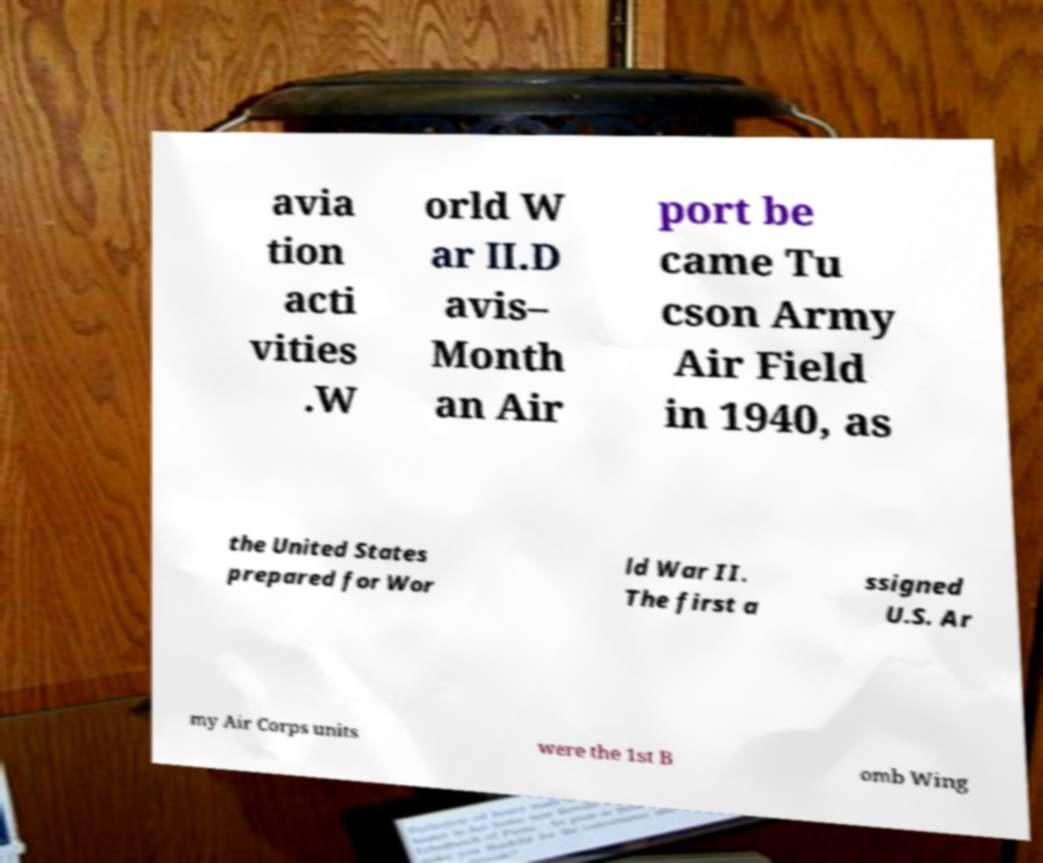Please identify and transcribe the text found in this image. avia tion acti vities .W orld W ar II.D avis– Month an Air port be came Tu cson Army Air Field in 1940, as the United States prepared for Wor ld War II. The first a ssigned U.S. Ar my Air Corps units were the 1st B omb Wing 